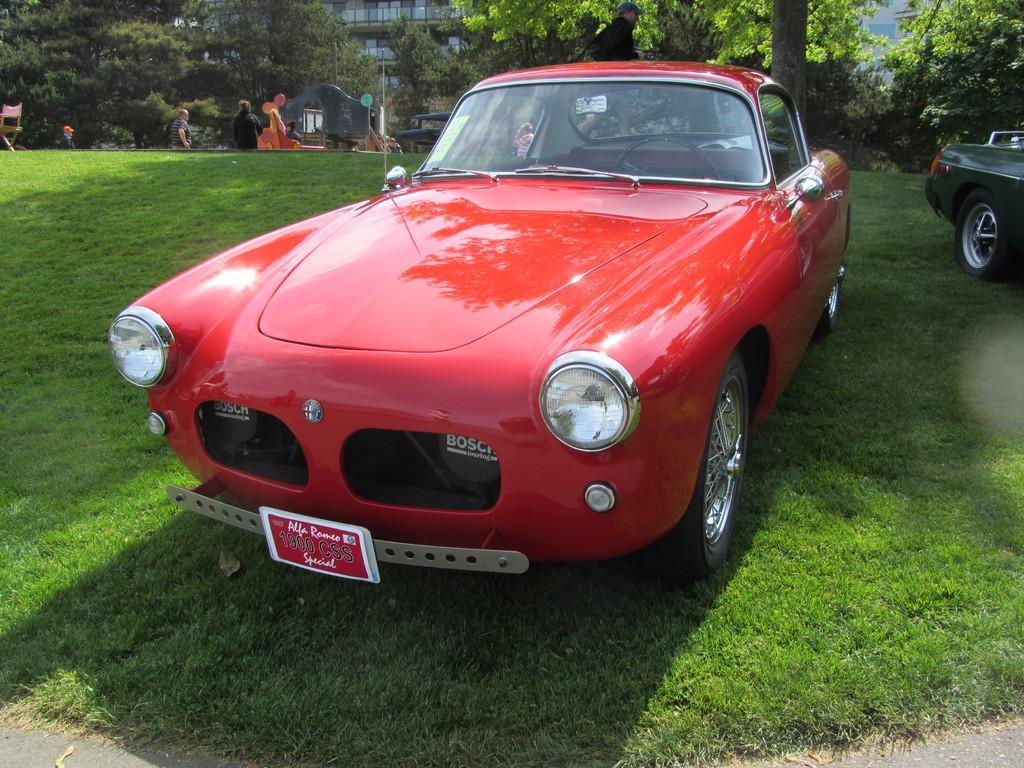How would you summarize this image in a sentence or two? This image is taken outdoors. At the bottom of the image there is a road and there is a ground with grass on it. In the background there is a building. There are a few trees. There are a few people. There is a bench and there is a pole and there is a chair on the ground. In the middle of the image a car is parked on the ground. The car is red in color. On the right side of the image a car is parked on the ground. 